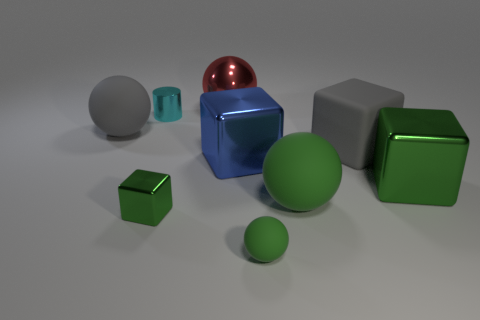Subtract all tiny green blocks. How many blocks are left? 3 Add 1 green balls. How many objects exist? 10 Subtract 1 spheres. How many spheres are left? 3 Subtract all blocks. How many objects are left? 5 Subtract all green blocks. How many blocks are left? 2 Add 4 shiny blocks. How many shiny blocks are left? 7 Add 1 small gray shiny spheres. How many small gray shiny spheres exist? 1 Subtract 0 cyan cubes. How many objects are left? 9 Subtract all green balls. Subtract all green cubes. How many balls are left? 2 Subtract all purple balls. How many red cylinders are left? 0 